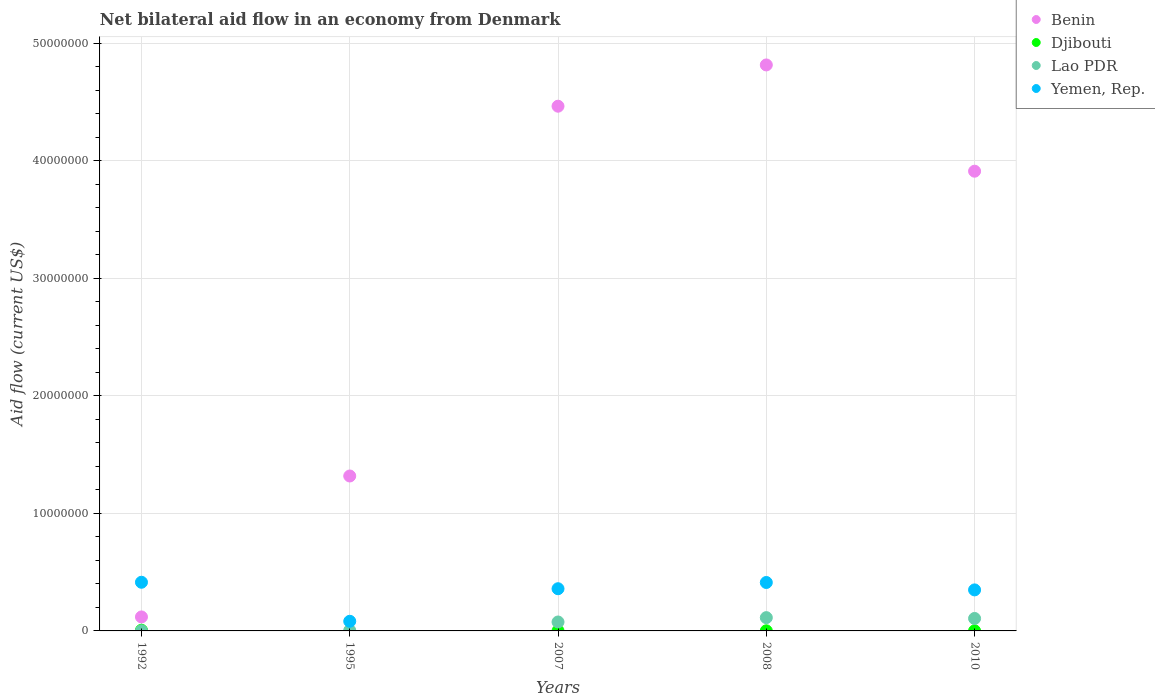How many different coloured dotlines are there?
Provide a short and direct response. 4. Is the number of dotlines equal to the number of legend labels?
Make the answer very short. No. What is the net bilateral aid flow in Benin in 2007?
Your response must be concise. 4.46e+07. Across all years, what is the maximum net bilateral aid flow in Benin?
Give a very brief answer. 4.82e+07. In which year was the net bilateral aid flow in Benin maximum?
Offer a terse response. 2008. What is the total net bilateral aid flow in Yemen, Rep. in the graph?
Ensure brevity in your answer.  1.62e+07. What is the difference between the net bilateral aid flow in Yemen, Rep. in 1992 and that in 2010?
Offer a very short reply. 6.50e+05. What is the difference between the net bilateral aid flow in Djibouti in 2010 and the net bilateral aid flow in Benin in 2007?
Your answer should be very brief. -4.46e+07. What is the average net bilateral aid flow in Djibouti per year?
Provide a succinct answer. 1.80e+04. In the year 2008, what is the difference between the net bilateral aid flow in Lao PDR and net bilateral aid flow in Djibouti?
Your response must be concise. 1.12e+06. In how many years, is the net bilateral aid flow in Yemen, Rep. greater than 16000000 US$?
Provide a short and direct response. 0. What is the ratio of the net bilateral aid flow in Yemen, Rep. in 2007 to that in 2010?
Provide a short and direct response. 1.03. What is the difference between the highest and the lowest net bilateral aid flow in Benin?
Your response must be concise. 4.70e+07. In how many years, is the net bilateral aid flow in Lao PDR greater than the average net bilateral aid flow in Lao PDR taken over all years?
Offer a very short reply. 3. Is the sum of the net bilateral aid flow in Lao PDR in 2007 and 2010 greater than the maximum net bilateral aid flow in Yemen, Rep. across all years?
Provide a short and direct response. No. Does the net bilateral aid flow in Djibouti monotonically increase over the years?
Make the answer very short. No. Does the graph contain grids?
Provide a succinct answer. Yes. Where does the legend appear in the graph?
Keep it short and to the point. Top right. How many legend labels are there?
Offer a very short reply. 4. How are the legend labels stacked?
Offer a very short reply. Vertical. What is the title of the graph?
Offer a terse response. Net bilateral aid flow in an economy from Denmark. What is the label or title of the X-axis?
Give a very brief answer. Years. What is the Aid flow (current US$) of Benin in 1992?
Ensure brevity in your answer.  1.19e+06. What is the Aid flow (current US$) of Yemen, Rep. in 1992?
Ensure brevity in your answer.  4.14e+06. What is the Aid flow (current US$) of Benin in 1995?
Keep it short and to the point. 1.32e+07. What is the Aid flow (current US$) of Djibouti in 1995?
Provide a succinct answer. 0. What is the Aid flow (current US$) of Yemen, Rep. in 1995?
Give a very brief answer. 8.20e+05. What is the Aid flow (current US$) of Benin in 2007?
Offer a terse response. 4.46e+07. What is the Aid flow (current US$) of Lao PDR in 2007?
Ensure brevity in your answer.  7.60e+05. What is the Aid flow (current US$) of Yemen, Rep. in 2007?
Provide a short and direct response. 3.59e+06. What is the Aid flow (current US$) of Benin in 2008?
Offer a terse response. 4.82e+07. What is the Aid flow (current US$) in Djibouti in 2008?
Provide a succinct answer. 10000. What is the Aid flow (current US$) in Lao PDR in 2008?
Your answer should be compact. 1.13e+06. What is the Aid flow (current US$) of Yemen, Rep. in 2008?
Offer a terse response. 4.12e+06. What is the Aid flow (current US$) in Benin in 2010?
Offer a terse response. 3.91e+07. What is the Aid flow (current US$) in Lao PDR in 2010?
Make the answer very short. 1.06e+06. What is the Aid flow (current US$) of Yemen, Rep. in 2010?
Provide a succinct answer. 3.49e+06. Across all years, what is the maximum Aid flow (current US$) in Benin?
Keep it short and to the point. 4.82e+07. Across all years, what is the maximum Aid flow (current US$) in Lao PDR?
Make the answer very short. 1.13e+06. Across all years, what is the maximum Aid flow (current US$) in Yemen, Rep.?
Offer a terse response. 4.14e+06. Across all years, what is the minimum Aid flow (current US$) in Benin?
Provide a short and direct response. 1.19e+06. Across all years, what is the minimum Aid flow (current US$) in Djibouti?
Give a very brief answer. 0. Across all years, what is the minimum Aid flow (current US$) in Lao PDR?
Offer a terse response. 10000. Across all years, what is the minimum Aid flow (current US$) of Yemen, Rep.?
Provide a short and direct response. 8.20e+05. What is the total Aid flow (current US$) in Benin in the graph?
Offer a very short reply. 1.46e+08. What is the total Aid flow (current US$) in Lao PDR in the graph?
Your answer should be compact. 3.00e+06. What is the total Aid flow (current US$) in Yemen, Rep. in the graph?
Your answer should be very brief. 1.62e+07. What is the difference between the Aid flow (current US$) of Benin in 1992 and that in 1995?
Your response must be concise. -1.20e+07. What is the difference between the Aid flow (current US$) in Yemen, Rep. in 1992 and that in 1995?
Provide a short and direct response. 3.32e+06. What is the difference between the Aid flow (current US$) in Benin in 1992 and that in 2007?
Provide a short and direct response. -4.34e+07. What is the difference between the Aid flow (current US$) in Djibouti in 1992 and that in 2007?
Your answer should be compact. 5.00e+04. What is the difference between the Aid flow (current US$) of Lao PDR in 1992 and that in 2007?
Your answer should be compact. -7.50e+05. What is the difference between the Aid flow (current US$) in Benin in 1992 and that in 2008?
Ensure brevity in your answer.  -4.70e+07. What is the difference between the Aid flow (current US$) in Lao PDR in 1992 and that in 2008?
Your response must be concise. -1.12e+06. What is the difference between the Aid flow (current US$) of Benin in 1992 and that in 2010?
Give a very brief answer. -3.79e+07. What is the difference between the Aid flow (current US$) of Lao PDR in 1992 and that in 2010?
Offer a very short reply. -1.05e+06. What is the difference between the Aid flow (current US$) in Yemen, Rep. in 1992 and that in 2010?
Provide a succinct answer. 6.50e+05. What is the difference between the Aid flow (current US$) of Benin in 1995 and that in 2007?
Make the answer very short. -3.15e+07. What is the difference between the Aid flow (current US$) in Lao PDR in 1995 and that in 2007?
Ensure brevity in your answer.  -7.20e+05. What is the difference between the Aid flow (current US$) in Yemen, Rep. in 1995 and that in 2007?
Offer a very short reply. -2.77e+06. What is the difference between the Aid flow (current US$) in Benin in 1995 and that in 2008?
Offer a terse response. -3.50e+07. What is the difference between the Aid flow (current US$) in Lao PDR in 1995 and that in 2008?
Provide a succinct answer. -1.09e+06. What is the difference between the Aid flow (current US$) of Yemen, Rep. in 1995 and that in 2008?
Your answer should be compact. -3.30e+06. What is the difference between the Aid flow (current US$) of Benin in 1995 and that in 2010?
Your response must be concise. -2.59e+07. What is the difference between the Aid flow (current US$) in Lao PDR in 1995 and that in 2010?
Provide a short and direct response. -1.02e+06. What is the difference between the Aid flow (current US$) in Yemen, Rep. in 1995 and that in 2010?
Make the answer very short. -2.67e+06. What is the difference between the Aid flow (current US$) of Benin in 2007 and that in 2008?
Offer a terse response. -3.51e+06. What is the difference between the Aid flow (current US$) in Lao PDR in 2007 and that in 2008?
Your answer should be compact. -3.70e+05. What is the difference between the Aid flow (current US$) of Yemen, Rep. in 2007 and that in 2008?
Ensure brevity in your answer.  -5.30e+05. What is the difference between the Aid flow (current US$) of Benin in 2007 and that in 2010?
Your answer should be compact. 5.53e+06. What is the difference between the Aid flow (current US$) in Yemen, Rep. in 2007 and that in 2010?
Provide a succinct answer. 1.00e+05. What is the difference between the Aid flow (current US$) of Benin in 2008 and that in 2010?
Your response must be concise. 9.04e+06. What is the difference between the Aid flow (current US$) of Djibouti in 2008 and that in 2010?
Provide a short and direct response. 0. What is the difference between the Aid flow (current US$) of Lao PDR in 2008 and that in 2010?
Ensure brevity in your answer.  7.00e+04. What is the difference between the Aid flow (current US$) in Yemen, Rep. in 2008 and that in 2010?
Make the answer very short. 6.30e+05. What is the difference between the Aid flow (current US$) of Benin in 1992 and the Aid flow (current US$) of Lao PDR in 1995?
Provide a short and direct response. 1.15e+06. What is the difference between the Aid flow (current US$) of Benin in 1992 and the Aid flow (current US$) of Yemen, Rep. in 1995?
Your response must be concise. 3.70e+05. What is the difference between the Aid flow (current US$) of Djibouti in 1992 and the Aid flow (current US$) of Lao PDR in 1995?
Give a very brief answer. 2.00e+04. What is the difference between the Aid flow (current US$) in Djibouti in 1992 and the Aid flow (current US$) in Yemen, Rep. in 1995?
Ensure brevity in your answer.  -7.60e+05. What is the difference between the Aid flow (current US$) of Lao PDR in 1992 and the Aid flow (current US$) of Yemen, Rep. in 1995?
Offer a terse response. -8.10e+05. What is the difference between the Aid flow (current US$) of Benin in 1992 and the Aid flow (current US$) of Djibouti in 2007?
Keep it short and to the point. 1.18e+06. What is the difference between the Aid flow (current US$) in Benin in 1992 and the Aid flow (current US$) in Lao PDR in 2007?
Your response must be concise. 4.30e+05. What is the difference between the Aid flow (current US$) of Benin in 1992 and the Aid flow (current US$) of Yemen, Rep. in 2007?
Give a very brief answer. -2.40e+06. What is the difference between the Aid flow (current US$) in Djibouti in 1992 and the Aid flow (current US$) in Lao PDR in 2007?
Offer a very short reply. -7.00e+05. What is the difference between the Aid flow (current US$) in Djibouti in 1992 and the Aid flow (current US$) in Yemen, Rep. in 2007?
Make the answer very short. -3.53e+06. What is the difference between the Aid flow (current US$) in Lao PDR in 1992 and the Aid flow (current US$) in Yemen, Rep. in 2007?
Your response must be concise. -3.58e+06. What is the difference between the Aid flow (current US$) in Benin in 1992 and the Aid flow (current US$) in Djibouti in 2008?
Offer a very short reply. 1.18e+06. What is the difference between the Aid flow (current US$) in Benin in 1992 and the Aid flow (current US$) in Yemen, Rep. in 2008?
Your response must be concise. -2.93e+06. What is the difference between the Aid flow (current US$) in Djibouti in 1992 and the Aid flow (current US$) in Lao PDR in 2008?
Your answer should be compact. -1.07e+06. What is the difference between the Aid flow (current US$) of Djibouti in 1992 and the Aid flow (current US$) of Yemen, Rep. in 2008?
Your answer should be compact. -4.06e+06. What is the difference between the Aid flow (current US$) in Lao PDR in 1992 and the Aid flow (current US$) in Yemen, Rep. in 2008?
Your response must be concise. -4.11e+06. What is the difference between the Aid flow (current US$) in Benin in 1992 and the Aid flow (current US$) in Djibouti in 2010?
Your answer should be compact. 1.18e+06. What is the difference between the Aid flow (current US$) in Benin in 1992 and the Aid flow (current US$) in Lao PDR in 2010?
Ensure brevity in your answer.  1.30e+05. What is the difference between the Aid flow (current US$) of Benin in 1992 and the Aid flow (current US$) of Yemen, Rep. in 2010?
Provide a short and direct response. -2.30e+06. What is the difference between the Aid flow (current US$) of Djibouti in 1992 and the Aid flow (current US$) of Yemen, Rep. in 2010?
Your response must be concise. -3.43e+06. What is the difference between the Aid flow (current US$) in Lao PDR in 1992 and the Aid flow (current US$) in Yemen, Rep. in 2010?
Keep it short and to the point. -3.48e+06. What is the difference between the Aid flow (current US$) of Benin in 1995 and the Aid flow (current US$) of Djibouti in 2007?
Ensure brevity in your answer.  1.32e+07. What is the difference between the Aid flow (current US$) of Benin in 1995 and the Aid flow (current US$) of Lao PDR in 2007?
Your answer should be very brief. 1.24e+07. What is the difference between the Aid flow (current US$) in Benin in 1995 and the Aid flow (current US$) in Yemen, Rep. in 2007?
Provide a succinct answer. 9.59e+06. What is the difference between the Aid flow (current US$) of Lao PDR in 1995 and the Aid flow (current US$) of Yemen, Rep. in 2007?
Ensure brevity in your answer.  -3.55e+06. What is the difference between the Aid flow (current US$) in Benin in 1995 and the Aid flow (current US$) in Djibouti in 2008?
Your answer should be very brief. 1.32e+07. What is the difference between the Aid flow (current US$) in Benin in 1995 and the Aid flow (current US$) in Lao PDR in 2008?
Offer a terse response. 1.20e+07. What is the difference between the Aid flow (current US$) in Benin in 1995 and the Aid flow (current US$) in Yemen, Rep. in 2008?
Make the answer very short. 9.06e+06. What is the difference between the Aid flow (current US$) of Lao PDR in 1995 and the Aid flow (current US$) of Yemen, Rep. in 2008?
Make the answer very short. -4.08e+06. What is the difference between the Aid flow (current US$) in Benin in 1995 and the Aid flow (current US$) in Djibouti in 2010?
Give a very brief answer. 1.32e+07. What is the difference between the Aid flow (current US$) of Benin in 1995 and the Aid flow (current US$) of Lao PDR in 2010?
Provide a succinct answer. 1.21e+07. What is the difference between the Aid flow (current US$) of Benin in 1995 and the Aid flow (current US$) of Yemen, Rep. in 2010?
Ensure brevity in your answer.  9.69e+06. What is the difference between the Aid flow (current US$) of Lao PDR in 1995 and the Aid flow (current US$) of Yemen, Rep. in 2010?
Offer a terse response. -3.45e+06. What is the difference between the Aid flow (current US$) of Benin in 2007 and the Aid flow (current US$) of Djibouti in 2008?
Make the answer very short. 4.46e+07. What is the difference between the Aid flow (current US$) in Benin in 2007 and the Aid flow (current US$) in Lao PDR in 2008?
Provide a short and direct response. 4.35e+07. What is the difference between the Aid flow (current US$) of Benin in 2007 and the Aid flow (current US$) of Yemen, Rep. in 2008?
Ensure brevity in your answer.  4.05e+07. What is the difference between the Aid flow (current US$) in Djibouti in 2007 and the Aid flow (current US$) in Lao PDR in 2008?
Your answer should be very brief. -1.12e+06. What is the difference between the Aid flow (current US$) in Djibouti in 2007 and the Aid flow (current US$) in Yemen, Rep. in 2008?
Offer a very short reply. -4.11e+06. What is the difference between the Aid flow (current US$) in Lao PDR in 2007 and the Aid flow (current US$) in Yemen, Rep. in 2008?
Make the answer very short. -3.36e+06. What is the difference between the Aid flow (current US$) of Benin in 2007 and the Aid flow (current US$) of Djibouti in 2010?
Your response must be concise. 4.46e+07. What is the difference between the Aid flow (current US$) of Benin in 2007 and the Aid flow (current US$) of Lao PDR in 2010?
Your answer should be compact. 4.36e+07. What is the difference between the Aid flow (current US$) of Benin in 2007 and the Aid flow (current US$) of Yemen, Rep. in 2010?
Provide a succinct answer. 4.12e+07. What is the difference between the Aid flow (current US$) of Djibouti in 2007 and the Aid flow (current US$) of Lao PDR in 2010?
Your answer should be compact. -1.05e+06. What is the difference between the Aid flow (current US$) of Djibouti in 2007 and the Aid flow (current US$) of Yemen, Rep. in 2010?
Ensure brevity in your answer.  -3.48e+06. What is the difference between the Aid flow (current US$) of Lao PDR in 2007 and the Aid flow (current US$) of Yemen, Rep. in 2010?
Provide a short and direct response. -2.73e+06. What is the difference between the Aid flow (current US$) in Benin in 2008 and the Aid flow (current US$) in Djibouti in 2010?
Offer a very short reply. 4.81e+07. What is the difference between the Aid flow (current US$) in Benin in 2008 and the Aid flow (current US$) in Lao PDR in 2010?
Keep it short and to the point. 4.71e+07. What is the difference between the Aid flow (current US$) in Benin in 2008 and the Aid flow (current US$) in Yemen, Rep. in 2010?
Provide a succinct answer. 4.47e+07. What is the difference between the Aid flow (current US$) of Djibouti in 2008 and the Aid flow (current US$) of Lao PDR in 2010?
Make the answer very short. -1.05e+06. What is the difference between the Aid flow (current US$) in Djibouti in 2008 and the Aid flow (current US$) in Yemen, Rep. in 2010?
Offer a terse response. -3.48e+06. What is the difference between the Aid flow (current US$) in Lao PDR in 2008 and the Aid flow (current US$) in Yemen, Rep. in 2010?
Provide a succinct answer. -2.36e+06. What is the average Aid flow (current US$) of Benin per year?
Give a very brief answer. 2.93e+07. What is the average Aid flow (current US$) in Djibouti per year?
Offer a terse response. 1.80e+04. What is the average Aid flow (current US$) of Lao PDR per year?
Provide a succinct answer. 6.00e+05. What is the average Aid flow (current US$) in Yemen, Rep. per year?
Ensure brevity in your answer.  3.23e+06. In the year 1992, what is the difference between the Aid flow (current US$) of Benin and Aid flow (current US$) of Djibouti?
Your answer should be very brief. 1.13e+06. In the year 1992, what is the difference between the Aid flow (current US$) of Benin and Aid flow (current US$) of Lao PDR?
Your answer should be compact. 1.18e+06. In the year 1992, what is the difference between the Aid flow (current US$) in Benin and Aid flow (current US$) in Yemen, Rep.?
Make the answer very short. -2.95e+06. In the year 1992, what is the difference between the Aid flow (current US$) of Djibouti and Aid flow (current US$) of Lao PDR?
Your answer should be compact. 5.00e+04. In the year 1992, what is the difference between the Aid flow (current US$) in Djibouti and Aid flow (current US$) in Yemen, Rep.?
Make the answer very short. -4.08e+06. In the year 1992, what is the difference between the Aid flow (current US$) in Lao PDR and Aid flow (current US$) in Yemen, Rep.?
Keep it short and to the point. -4.13e+06. In the year 1995, what is the difference between the Aid flow (current US$) of Benin and Aid flow (current US$) of Lao PDR?
Provide a succinct answer. 1.31e+07. In the year 1995, what is the difference between the Aid flow (current US$) in Benin and Aid flow (current US$) in Yemen, Rep.?
Offer a terse response. 1.24e+07. In the year 1995, what is the difference between the Aid flow (current US$) of Lao PDR and Aid flow (current US$) of Yemen, Rep.?
Your answer should be compact. -7.80e+05. In the year 2007, what is the difference between the Aid flow (current US$) in Benin and Aid flow (current US$) in Djibouti?
Offer a terse response. 4.46e+07. In the year 2007, what is the difference between the Aid flow (current US$) of Benin and Aid flow (current US$) of Lao PDR?
Your answer should be compact. 4.39e+07. In the year 2007, what is the difference between the Aid flow (current US$) of Benin and Aid flow (current US$) of Yemen, Rep.?
Your response must be concise. 4.10e+07. In the year 2007, what is the difference between the Aid flow (current US$) of Djibouti and Aid flow (current US$) of Lao PDR?
Your answer should be very brief. -7.50e+05. In the year 2007, what is the difference between the Aid flow (current US$) of Djibouti and Aid flow (current US$) of Yemen, Rep.?
Your answer should be compact. -3.58e+06. In the year 2007, what is the difference between the Aid flow (current US$) of Lao PDR and Aid flow (current US$) of Yemen, Rep.?
Make the answer very short. -2.83e+06. In the year 2008, what is the difference between the Aid flow (current US$) in Benin and Aid flow (current US$) in Djibouti?
Give a very brief answer. 4.81e+07. In the year 2008, what is the difference between the Aid flow (current US$) of Benin and Aid flow (current US$) of Lao PDR?
Provide a short and direct response. 4.70e+07. In the year 2008, what is the difference between the Aid flow (current US$) in Benin and Aid flow (current US$) in Yemen, Rep.?
Offer a very short reply. 4.40e+07. In the year 2008, what is the difference between the Aid flow (current US$) in Djibouti and Aid flow (current US$) in Lao PDR?
Ensure brevity in your answer.  -1.12e+06. In the year 2008, what is the difference between the Aid flow (current US$) of Djibouti and Aid flow (current US$) of Yemen, Rep.?
Provide a short and direct response. -4.11e+06. In the year 2008, what is the difference between the Aid flow (current US$) in Lao PDR and Aid flow (current US$) in Yemen, Rep.?
Your answer should be very brief. -2.99e+06. In the year 2010, what is the difference between the Aid flow (current US$) in Benin and Aid flow (current US$) in Djibouti?
Your answer should be very brief. 3.91e+07. In the year 2010, what is the difference between the Aid flow (current US$) of Benin and Aid flow (current US$) of Lao PDR?
Provide a short and direct response. 3.80e+07. In the year 2010, what is the difference between the Aid flow (current US$) of Benin and Aid flow (current US$) of Yemen, Rep.?
Ensure brevity in your answer.  3.56e+07. In the year 2010, what is the difference between the Aid flow (current US$) in Djibouti and Aid flow (current US$) in Lao PDR?
Provide a short and direct response. -1.05e+06. In the year 2010, what is the difference between the Aid flow (current US$) in Djibouti and Aid flow (current US$) in Yemen, Rep.?
Provide a short and direct response. -3.48e+06. In the year 2010, what is the difference between the Aid flow (current US$) of Lao PDR and Aid flow (current US$) of Yemen, Rep.?
Your response must be concise. -2.43e+06. What is the ratio of the Aid flow (current US$) of Benin in 1992 to that in 1995?
Keep it short and to the point. 0.09. What is the ratio of the Aid flow (current US$) of Yemen, Rep. in 1992 to that in 1995?
Provide a short and direct response. 5.05. What is the ratio of the Aid flow (current US$) of Benin in 1992 to that in 2007?
Provide a short and direct response. 0.03. What is the ratio of the Aid flow (current US$) of Djibouti in 1992 to that in 2007?
Your answer should be compact. 6. What is the ratio of the Aid flow (current US$) in Lao PDR in 1992 to that in 2007?
Offer a very short reply. 0.01. What is the ratio of the Aid flow (current US$) of Yemen, Rep. in 1992 to that in 2007?
Make the answer very short. 1.15. What is the ratio of the Aid flow (current US$) in Benin in 1992 to that in 2008?
Make the answer very short. 0.02. What is the ratio of the Aid flow (current US$) in Djibouti in 1992 to that in 2008?
Offer a terse response. 6. What is the ratio of the Aid flow (current US$) in Lao PDR in 1992 to that in 2008?
Offer a very short reply. 0.01. What is the ratio of the Aid flow (current US$) of Yemen, Rep. in 1992 to that in 2008?
Your answer should be very brief. 1. What is the ratio of the Aid flow (current US$) in Benin in 1992 to that in 2010?
Your response must be concise. 0.03. What is the ratio of the Aid flow (current US$) of Djibouti in 1992 to that in 2010?
Your response must be concise. 6. What is the ratio of the Aid flow (current US$) of Lao PDR in 1992 to that in 2010?
Provide a succinct answer. 0.01. What is the ratio of the Aid flow (current US$) of Yemen, Rep. in 1992 to that in 2010?
Make the answer very short. 1.19. What is the ratio of the Aid flow (current US$) of Benin in 1995 to that in 2007?
Make the answer very short. 0.3. What is the ratio of the Aid flow (current US$) in Lao PDR in 1995 to that in 2007?
Your answer should be compact. 0.05. What is the ratio of the Aid flow (current US$) of Yemen, Rep. in 1995 to that in 2007?
Make the answer very short. 0.23. What is the ratio of the Aid flow (current US$) of Benin in 1995 to that in 2008?
Make the answer very short. 0.27. What is the ratio of the Aid flow (current US$) in Lao PDR in 1995 to that in 2008?
Provide a succinct answer. 0.04. What is the ratio of the Aid flow (current US$) in Yemen, Rep. in 1995 to that in 2008?
Provide a succinct answer. 0.2. What is the ratio of the Aid flow (current US$) in Benin in 1995 to that in 2010?
Make the answer very short. 0.34. What is the ratio of the Aid flow (current US$) of Lao PDR in 1995 to that in 2010?
Keep it short and to the point. 0.04. What is the ratio of the Aid flow (current US$) in Yemen, Rep. in 1995 to that in 2010?
Give a very brief answer. 0.23. What is the ratio of the Aid flow (current US$) of Benin in 2007 to that in 2008?
Give a very brief answer. 0.93. What is the ratio of the Aid flow (current US$) in Djibouti in 2007 to that in 2008?
Ensure brevity in your answer.  1. What is the ratio of the Aid flow (current US$) of Lao PDR in 2007 to that in 2008?
Your answer should be compact. 0.67. What is the ratio of the Aid flow (current US$) in Yemen, Rep. in 2007 to that in 2008?
Give a very brief answer. 0.87. What is the ratio of the Aid flow (current US$) in Benin in 2007 to that in 2010?
Your answer should be compact. 1.14. What is the ratio of the Aid flow (current US$) of Djibouti in 2007 to that in 2010?
Keep it short and to the point. 1. What is the ratio of the Aid flow (current US$) of Lao PDR in 2007 to that in 2010?
Your answer should be compact. 0.72. What is the ratio of the Aid flow (current US$) of Yemen, Rep. in 2007 to that in 2010?
Make the answer very short. 1.03. What is the ratio of the Aid flow (current US$) of Benin in 2008 to that in 2010?
Keep it short and to the point. 1.23. What is the ratio of the Aid flow (current US$) of Lao PDR in 2008 to that in 2010?
Make the answer very short. 1.07. What is the ratio of the Aid flow (current US$) of Yemen, Rep. in 2008 to that in 2010?
Your response must be concise. 1.18. What is the difference between the highest and the second highest Aid flow (current US$) in Benin?
Ensure brevity in your answer.  3.51e+06. What is the difference between the highest and the lowest Aid flow (current US$) of Benin?
Keep it short and to the point. 4.70e+07. What is the difference between the highest and the lowest Aid flow (current US$) of Lao PDR?
Your response must be concise. 1.12e+06. What is the difference between the highest and the lowest Aid flow (current US$) in Yemen, Rep.?
Offer a very short reply. 3.32e+06. 